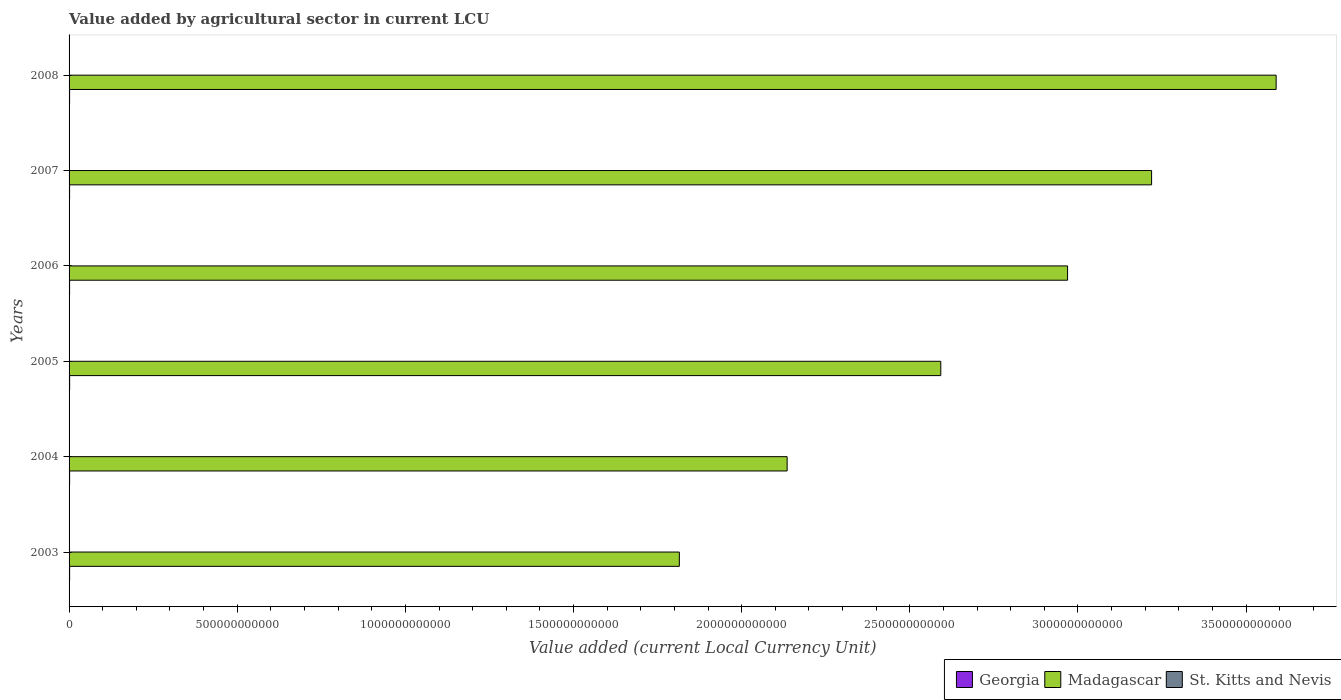How many different coloured bars are there?
Make the answer very short. 3. How many groups of bars are there?
Provide a short and direct response. 6. Are the number of bars on each tick of the Y-axis equal?
Make the answer very short. Yes. What is the label of the 4th group of bars from the top?
Ensure brevity in your answer.  2005. What is the value added by agricultural sector in St. Kitts and Nevis in 2006?
Your response must be concise. 2.07e+07. Across all years, what is the maximum value added by agricultural sector in St. Kitts and Nevis?
Keep it short and to the point. 2.57e+07. Across all years, what is the minimum value added by agricultural sector in St. Kitts and Nevis?
Your answer should be compact. 2.07e+07. In which year was the value added by agricultural sector in Georgia maximum?
Provide a succinct answer. 2005. What is the total value added by agricultural sector in Georgia in the graph?
Ensure brevity in your answer.  9.64e+09. What is the difference between the value added by agricultural sector in Georgia in 2003 and that in 2004?
Provide a short and direct response. 4.23e+07. What is the difference between the value added by agricultural sector in Georgia in 2005 and the value added by agricultural sector in Madagascar in 2007?
Your response must be concise. -3.22e+12. What is the average value added by agricultural sector in Madagascar per year?
Your answer should be compact. 2.72e+12. In the year 2006, what is the difference between the value added by agricultural sector in St. Kitts and Nevis and value added by agricultural sector in Georgia?
Offer a very short reply. -1.52e+09. In how many years, is the value added by agricultural sector in St. Kitts and Nevis greater than 3200000000000 LCU?
Give a very brief answer. 0. What is the ratio of the value added by agricultural sector in Madagascar in 2005 to that in 2008?
Provide a succinct answer. 0.72. What is the difference between the highest and the second highest value added by agricultural sector in Madagascar?
Ensure brevity in your answer.  3.70e+11. What is the difference between the highest and the lowest value added by agricultural sector in Madagascar?
Make the answer very short. 1.77e+12. Is the sum of the value added by agricultural sector in Madagascar in 2004 and 2005 greater than the maximum value added by agricultural sector in St. Kitts and Nevis across all years?
Your answer should be compact. Yes. What does the 1st bar from the top in 2003 represents?
Keep it short and to the point. St. Kitts and Nevis. What does the 3rd bar from the bottom in 2005 represents?
Offer a terse response. St. Kitts and Nevis. How many bars are there?
Ensure brevity in your answer.  18. Are all the bars in the graph horizontal?
Your answer should be very brief. Yes. How many years are there in the graph?
Provide a short and direct response. 6. What is the difference between two consecutive major ticks on the X-axis?
Keep it short and to the point. 5.00e+11. Are the values on the major ticks of X-axis written in scientific E-notation?
Offer a very short reply. No. Does the graph contain grids?
Your response must be concise. No. What is the title of the graph?
Your answer should be compact. Value added by agricultural sector in current LCU. Does "Greece" appear as one of the legend labels in the graph?
Provide a short and direct response. No. What is the label or title of the X-axis?
Offer a terse response. Value added (current Local Currency Unit). What is the Value added (current Local Currency Unit) of Georgia in 2003?
Make the answer very short. 1.65e+09. What is the Value added (current Local Currency Unit) in Madagascar in 2003?
Your answer should be compact. 1.81e+12. What is the Value added (current Local Currency Unit) in St. Kitts and Nevis in 2003?
Provide a short and direct response. 2.26e+07. What is the Value added (current Local Currency Unit) of Georgia in 2004?
Offer a very short reply. 1.61e+09. What is the Value added (current Local Currency Unit) of Madagascar in 2004?
Ensure brevity in your answer.  2.14e+12. What is the Value added (current Local Currency Unit) of St. Kitts and Nevis in 2004?
Make the answer very short. 2.44e+07. What is the Value added (current Local Currency Unit) in Georgia in 2005?
Offer a terse response. 1.72e+09. What is the Value added (current Local Currency Unit) in Madagascar in 2005?
Your answer should be compact. 2.59e+12. What is the Value added (current Local Currency Unit) in St. Kitts and Nevis in 2005?
Ensure brevity in your answer.  2.45e+07. What is the Value added (current Local Currency Unit) in Georgia in 2006?
Provide a short and direct response. 1.54e+09. What is the Value added (current Local Currency Unit) of Madagascar in 2006?
Your answer should be very brief. 2.97e+12. What is the Value added (current Local Currency Unit) of St. Kitts and Nevis in 2006?
Keep it short and to the point. 2.07e+07. What is the Value added (current Local Currency Unit) in Georgia in 2007?
Offer a terse response. 1.56e+09. What is the Value added (current Local Currency Unit) in Madagascar in 2007?
Offer a very short reply. 3.22e+12. What is the Value added (current Local Currency Unit) in St. Kitts and Nevis in 2007?
Your answer should be compact. 2.15e+07. What is the Value added (current Local Currency Unit) in Georgia in 2008?
Provide a succinct answer. 1.55e+09. What is the Value added (current Local Currency Unit) of Madagascar in 2008?
Provide a short and direct response. 3.59e+12. What is the Value added (current Local Currency Unit) of St. Kitts and Nevis in 2008?
Provide a short and direct response. 2.57e+07. Across all years, what is the maximum Value added (current Local Currency Unit) in Georgia?
Give a very brief answer. 1.72e+09. Across all years, what is the maximum Value added (current Local Currency Unit) in Madagascar?
Provide a succinct answer. 3.59e+12. Across all years, what is the maximum Value added (current Local Currency Unit) in St. Kitts and Nevis?
Offer a terse response. 2.57e+07. Across all years, what is the minimum Value added (current Local Currency Unit) of Georgia?
Your answer should be compact. 1.54e+09. Across all years, what is the minimum Value added (current Local Currency Unit) in Madagascar?
Make the answer very short. 1.81e+12. Across all years, what is the minimum Value added (current Local Currency Unit) in St. Kitts and Nevis?
Keep it short and to the point. 2.07e+07. What is the total Value added (current Local Currency Unit) in Georgia in the graph?
Your answer should be very brief. 9.64e+09. What is the total Value added (current Local Currency Unit) of Madagascar in the graph?
Ensure brevity in your answer.  1.63e+13. What is the total Value added (current Local Currency Unit) of St. Kitts and Nevis in the graph?
Your answer should be compact. 1.39e+08. What is the difference between the Value added (current Local Currency Unit) of Georgia in 2003 and that in 2004?
Your answer should be very brief. 4.23e+07. What is the difference between the Value added (current Local Currency Unit) in Madagascar in 2003 and that in 2004?
Offer a terse response. -3.21e+11. What is the difference between the Value added (current Local Currency Unit) in St. Kitts and Nevis in 2003 and that in 2004?
Ensure brevity in your answer.  -1.83e+06. What is the difference between the Value added (current Local Currency Unit) of Georgia in 2003 and that in 2005?
Your answer should be compact. -6.34e+07. What is the difference between the Value added (current Local Currency Unit) of Madagascar in 2003 and that in 2005?
Provide a short and direct response. -7.77e+11. What is the difference between the Value added (current Local Currency Unit) of St. Kitts and Nevis in 2003 and that in 2005?
Keep it short and to the point. -1.98e+06. What is the difference between the Value added (current Local Currency Unit) of Georgia in 2003 and that in 2006?
Your answer should be compact. 1.09e+08. What is the difference between the Value added (current Local Currency Unit) in Madagascar in 2003 and that in 2006?
Your answer should be compact. -1.15e+12. What is the difference between the Value added (current Local Currency Unit) of St. Kitts and Nevis in 2003 and that in 2006?
Keep it short and to the point. 1.88e+06. What is the difference between the Value added (current Local Currency Unit) of Georgia in 2003 and that in 2007?
Offer a very short reply. 9.02e+07. What is the difference between the Value added (current Local Currency Unit) in Madagascar in 2003 and that in 2007?
Ensure brevity in your answer.  -1.40e+12. What is the difference between the Value added (current Local Currency Unit) in St. Kitts and Nevis in 2003 and that in 2007?
Your answer should be very brief. 1.06e+06. What is the difference between the Value added (current Local Currency Unit) in Georgia in 2003 and that in 2008?
Provide a short and direct response. 1.02e+08. What is the difference between the Value added (current Local Currency Unit) in Madagascar in 2003 and that in 2008?
Keep it short and to the point. -1.77e+12. What is the difference between the Value added (current Local Currency Unit) of St. Kitts and Nevis in 2003 and that in 2008?
Your answer should be very brief. -3.13e+06. What is the difference between the Value added (current Local Currency Unit) of Georgia in 2004 and that in 2005?
Your answer should be compact. -1.06e+08. What is the difference between the Value added (current Local Currency Unit) in Madagascar in 2004 and that in 2005?
Make the answer very short. -4.57e+11. What is the difference between the Value added (current Local Currency Unit) of St. Kitts and Nevis in 2004 and that in 2005?
Give a very brief answer. -1.56e+05. What is the difference between the Value added (current Local Currency Unit) of Georgia in 2004 and that in 2006?
Give a very brief answer. 6.63e+07. What is the difference between the Value added (current Local Currency Unit) of Madagascar in 2004 and that in 2006?
Offer a terse response. -8.34e+11. What is the difference between the Value added (current Local Currency Unit) of St. Kitts and Nevis in 2004 and that in 2006?
Your answer should be very brief. 3.71e+06. What is the difference between the Value added (current Local Currency Unit) in Georgia in 2004 and that in 2007?
Keep it short and to the point. 4.80e+07. What is the difference between the Value added (current Local Currency Unit) in Madagascar in 2004 and that in 2007?
Ensure brevity in your answer.  -1.08e+12. What is the difference between the Value added (current Local Currency Unit) of St. Kitts and Nevis in 2004 and that in 2007?
Give a very brief answer. 2.89e+06. What is the difference between the Value added (current Local Currency Unit) in Georgia in 2004 and that in 2008?
Provide a short and direct response. 5.96e+07. What is the difference between the Value added (current Local Currency Unit) of Madagascar in 2004 and that in 2008?
Offer a very short reply. -1.45e+12. What is the difference between the Value added (current Local Currency Unit) in St. Kitts and Nevis in 2004 and that in 2008?
Make the answer very short. -1.30e+06. What is the difference between the Value added (current Local Currency Unit) of Georgia in 2005 and that in 2006?
Provide a short and direct response. 1.72e+08. What is the difference between the Value added (current Local Currency Unit) in Madagascar in 2005 and that in 2006?
Provide a short and direct response. -3.77e+11. What is the difference between the Value added (current Local Currency Unit) in St. Kitts and Nevis in 2005 and that in 2006?
Ensure brevity in your answer.  3.87e+06. What is the difference between the Value added (current Local Currency Unit) in Georgia in 2005 and that in 2007?
Make the answer very short. 1.54e+08. What is the difference between the Value added (current Local Currency Unit) of Madagascar in 2005 and that in 2007?
Keep it short and to the point. -6.27e+11. What is the difference between the Value added (current Local Currency Unit) in St. Kitts and Nevis in 2005 and that in 2007?
Keep it short and to the point. 3.05e+06. What is the difference between the Value added (current Local Currency Unit) in Georgia in 2005 and that in 2008?
Your answer should be compact. 1.65e+08. What is the difference between the Value added (current Local Currency Unit) of Madagascar in 2005 and that in 2008?
Provide a short and direct response. -9.97e+11. What is the difference between the Value added (current Local Currency Unit) in St. Kitts and Nevis in 2005 and that in 2008?
Offer a very short reply. -1.14e+06. What is the difference between the Value added (current Local Currency Unit) of Georgia in 2006 and that in 2007?
Your answer should be compact. -1.84e+07. What is the difference between the Value added (current Local Currency Unit) in Madagascar in 2006 and that in 2007?
Keep it short and to the point. -2.50e+11. What is the difference between the Value added (current Local Currency Unit) in St. Kitts and Nevis in 2006 and that in 2007?
Provide a succinct answer. -8.18e+05. What is the difference between the Value added (current Local Currency Unit) in Georgia in 2006 and that in 2008?
Keep it short and to the point. -6.71e+06. What is the difference between the Value added (current Local Currency Unit) of Madagascar in 2006 and that in 2008?
Offer a terse response. -6.20e+11. What is the difference between the Value added (current Local Currency Unit) in St. Kitts and Nevis in 2006 and that in 2008?
Offer a very short reply. -5.01e+06. What is the difference between the Value added (current Local Currency Unit) of Georgia in 2007 and that in 2008?
Your answer should be compact. 1.17e+07. What is the difference between the Value added (current Local Currency Unit) in Madagascar in 2007 and that in 2008?
Keep it short and to the point. -3.70e+11. What is the difference between the Value added (current Local Currency Unit) of St. Kitts and Nevis in 2007 and that in 2008?
Provide a succinct answer. -4.19e+06. What is the difference between the Value added (current Local Currency Unit) of Georgia in 2003 and the Value added (current Local Currency Unit) of Madagascar in 2004?
Provide a short and direct response. -2.13e+12. What is the difference between the Value added (current Local Currency Unit) of Georgia in 2003 and the Value added (current Local Currency Unit) of St. Kitts and Nevis in 2004?
Provide a succinct answer. 1.63e+09. What is the difference between the Value added (current Local Currency Unit) of Madagascar in 2003 and the Value added (current Local Currency Unit) of St. Kitts and Nevis in 2004?
Ensure brevity in your answer.  1.81e+12. What is the difference between the Value added (current Local Currency Unit) in Georgia in 2003 and the Value added (current Local Currency Unit) in Madagascar in 2005?
Ensure brevity in your answer.  -2.59e+12. What is the difference between the Value added (current Local Currency Unit) of Georgia in 2003 and the Value added (current Local Currency Unit) of St. Kitts and Nevis in 2005?
Keep it short and to the point. 1.63e+09. What is the difference between the Value added (current Local Currency Unit) in Madagascar in 2003 and the Value added (current Local Currency Unit) in St. Kitts and Nevis in 2005?
Your answer should be compact. 1.81e+12. What is the difference between the Value added (current Local Currency Unit) in Georgia in 2003 and the Value added (current Local Currency Unit) in Madagascar in 2006?
Offer a terse response. -2.97e+12. What is the difference between the Value added (current Local Currency Unit) in Georgia in 2003 and the Value added (current Local Currency Unit) in St. Kitts and Nevis in 2006?
Provide a succinct answer. 1.63e+09. What is the difference between the Value added (current Local Currency Unit) in Madagascar in 2003 and the Value added (current Local Currency Unit) in St. Kitts and Nevis in 2006?
Your answer should be very brief. 1.81e+12. What is the difference between the Value added (current Local Currency Unit) in Georgia in 2003 and the Value added (current Local Currency Unit) in Madagascar in 2007?
Offer a very short reply. -3.22e+12. What is the difference between the Value added (current Local Currency Unit) in Georgia in 2003 and the Value added (current Local Currency Unit) in St. Kitts and Nevis in 2007?
Your response must be concise. 1.63e+09. What is the difference between the Value added (current Local Currency Unit) in Madagascar in 2003 and the Value added (current Local Currency Unit) in St. Kitts and Nevis in 2007?
Ensure brevity in your answer.  1.81e+12. What is the difference between the Value added (current Local Currency Unit) in Georgia in 2003 and the Value added (current Local Currency Unit) in Madagascar in 2008?
Your response must be concise. -3.59e+12. What is the difference between the Value added (current Local Currency Unit) in Georgia in 2003 and the Value added (current Local Currency Unit) in St. Kitts and Nevis in 2008?
Your answer should be very brief. 1.63e+09. What is the difference between the Value added (current Local Currency Unit) in Madagascar in 2003 and the Value added (current Local Currency Unit) in St. Kitts and Nevis in 2008?
Keep it short and to the point. 1.81e+12. What is the difference between the Value added (current Local Currency Unit) in Georgia in 2004 and the Value added (current Local Currency Unit) in Madagascar in 2005?
Your answer should be compact. -2.59e+12. What is the difference between the Value added (current Local Currency Unit) of Georgia in 2004 and the Value added (current Local Currency Unit) of St. Kitts and Nevis in 2005?
Make the answer very short. 1.59e+09. What is the difference between the Value added (current Local Currency Unit) of Madagascar in 2004 and the Value added (current Local Currency Unit) of St. Kitts and Nevis in 2005?
Give a very brief answer. 2.14e+12. What is the difference between the Value added (current Local Currency Unit) of Georgia in 2004 and the Value added (current Local Currency Unit) of Madagascar in 2006?
Give a very brief answer. -2.97e+12. What is the difference between the Value added (current Local Currency Unit) in Georgia in 2004 and the Value added (current Local Currency Unit) in St. Kitts and Nevis in 2006?
Make the answer very short. 1.59e+09. What is the difference between the Value added (current Local Currency Unit) of Madagascar in 2004 and the Value added (current Local Currency Unit) of St. Kitts and Nevis in 2006?
Your answer should be very brief. 2.14e+12. What is the difference between the Value added (current Local Currency Unit) in Georgia in 2004 and the Value added (current Local Currency Unit) in Madagascar in 2007?
Make the answer very short. -3.22e+12. What is the difference between the Value added (current Local Currency Unit) of Georgia in 2004 and the Value added (current Local Currency Unit) of St. Kitts and Nevis in 2007?
Ensure brevity in your answer.  1.59e+09. What is the difference between the Value added (current Local Currency Unit) in Madagascar in 2004 and the Value added (current Local Currency Unit) in St. Kitts and Nevis in 2007?
Offer a terse response. 2.14e+12. What is the difference between the Value added (current Local Currency Unit) of Georgia in 2004 and the Value added (current Local Currency Unit) of Madagascar in 2008?
Your answer should be compact. -3.59e+12. What is the difference between the Value added (current Local Currency Unit) in Georgia in 2004 and the Value added (current Local Currency Unit) in St. Kitts and Nevis in 2008?
Your answer should be very brief. 1.58e+09. What is the difference between the Value added (current Local Currency Unit) of Madagascar in 2004 and the Value added (current Local Currency Unit) of St. Kitts and Nevis in 2008?
Your answer should be compact. 2.14e+12. What is the difference between the Value added (current Local Currency Unit) in Georgia in 2005 and the Value added (current Local Currency Unit) in Madagascar in 2006?
Your answer should be compact. -2.97e+12. What is the difference between the Value added (current Local Currency Unit) of Georgia in 2005 and the Value added (current Local Currency Unit) of St. Kitts and Nevis in 2006?
Your answer should be compact. 1.70e+09. What is the difference between the Value added (current Local Currency Unit) in Madagascar in 2005 and the Value added (current Local Currency Unit) in St. Kitts and Nevis in 2006?
Make the answer very short. 2.59e+12. What is the difference between the Value added (current Local Currency Unit) of Georgia in 2005 and the Value added (current Local Currency Unit) of Madagascar in 2007?
Provide a short and direct response. -3.22e+12. What is the difference between the Value added (current Local Currency Unit) in Georgia in 2005 and the Value added (current Local Currency Unit) in St. Kitts and Nevis in 2007?
Offer a terse response. 1.69e+09. What is the difference between the Value added (current Local Currency Unit) in Madagascar in 2005 and the Value added (current Local Currency Unit) in St. Kitts and Nevis in 2007?
Give a very brief answer. 2.59e+12. What is the difference between the Value added (current Local Currency Unit) of Georgia in 2005 and the Value added (current Local Currency Unit) of Madagascar in 2008?
Make the answer very short. -3.59e+12. What is the difference between the Value added (current Local Currency Unit) of Georgia in 2005 and the Value added (current Local Currency Unit) of St. Kitts and Nevis in 2008?
Keep it short and to the point. 1.69e+09. What is the difference between the Value added (current Local Currency Unit) in Madagascar in 2005 and the Value added (current Local Currency Unit) in St. Kitts and Nevis in 2008?
Keep it short and to the point. 2.59e+12. What is the difference between the Value added (current Local Currency Unit) in Georgia in 2006 and the Value added (current Local Currency Unit) in Madagascar in 2007?
Make the answer very short. -3.22e+12. What is the difference between the Value added (current Local Currency Unit) of Georgia in 2006 and the Value added (current Local Currency Unit) of St. Kitts and Nevis in 2007?
Your answer should be very brief. 1.52e+09. What is the difference between the Value added (current Local Currency Unit) in Madagascar in 2006 and the Value added (current Local Currency Unit) in St. Kitts and Nevis in 2007?
Keep it short and to the point. 2.97e+12. What is the difference between the Value added (current Local Currency Unit) of Georgia in 2006 and the Value added (current Local Currency Unit) of Madagascar in 2008?
Offer a terse response. -3.59e+12. What is the difference between the Value added (current Local Currency Unit) in Georgia in 2006 and the Value added (current Local Currency Unit) in St. Kitts and Nevis in 2008?
Your answer should be compact. 1.52e+09. What is the difference between the Value added (current Local Currency Unit) in Madagascar in 2006 and the Value added (current Local Currency Unit) in St. Kitts and Nevis in 2008?
Make the answer very short. 2.97e+12. What is the difference between the Value added (current Local Currency Unit) in Georgia in 2007 and the Value added (current Local Currency Unit) in Madagascar in 2008?
Keep it short and to the point. -3.59e+12. What is the difference between the Value added (current Local Currency Unit) of Georgia in 2007 and the Value added (current Local Currency Unit) of St. Kitts and Nevis in 2008?
Give a very brief answer. 1.54e+09. What is the difference between the Value added (current Local Currency Unit) of Madagascar in 2007 and the Value added (current Local Currency Unit) of St. Kitts and Nevis in 2008?
Your answer should be very brief. 3.22e+12. What is the average Value added (current Local Currency Unit) in Georgia per year?
Provide a succinct answer. 1.61e+09. What is the average Value added (current Local Currency Unit) of Madagascar per year?
Provide a short and direct response. 2.72e+12. What is the average Value added (current Local Currency Unit) of St. Kitts and Nevis per year?
Provide a short and direct response. 2.32e+07. In the year 2003, what is the difference between the Value added (current Local Currency Unit) of Georgia and Value added (current Local Currency Unit) of Madagascar?
Your answer should be compact. -1.81e+12. In the year 2003, what is the difference between the Value added (current Local Currency Unit) in Georgia and Value added (current Local Currency Unit) in St. Kitts and Nevis?
Keep it short and to the point. 1.63e+09. In the year 2003, what is the difference between the Value added (current Local Currency Unit) in Madagascar and Value added (current Local Currency Unit) in St. Kitts and Nevis?
Your answer should be compact. 1.81e+12. In the year 2004, what is the difference between the Value added (current Local Currency Unit) in Georgia and Value added (current Local Currency Unit) in Madagascar?
Your answer should be compact. -2.13e+12. In the year 2004, what is the difference between the Value added (current Local Currency Unit) of Georgia and Value added (current Local Currency Unit) of St. Kitts and Nevis?
Give a very brief answer. 1.59e+09. In the year 2004, what is the difference between the Value added (current Local Currency Unit) of Madagascar and Value added (current Local Currency Unit) of St. Kitts and Nevis?
Provide a succinct answer. 2.14e+12. In the year 2005, what is the difference between the Value added (current Local Currency Unit) in Georgia and Value added (current Local Currency Unit) in Madagascar?
Provide a succinct answer. -2.59e+12. In the year 2005, what is the difference between the Value added (current Local Currency Unit) in Georgia and Value added (current Local Currency Unit) in St. Kitts and Nevis?
Offer a terse response. 1.69e+09. In the year 2005, what is the difference between the Value added (current Local Currency Unit) in Madagascar and Value added (current Local Currency Unit) in St. Kitts and Nevis?
Your response must be concise. 2.59e+12. In the year 2006, what is the difference between the Value added (current Local Currency Unit) of Georgia and Value added (current Local Currency Unit) of Madagascar?
Provide a succinct answer. -2.97e+12. In the year 2006, what is the difference between the Value added (current Local Currency Unit) of Georgia and Value added (current Local Currency Unit) of St. Kitts and Nevis?
Your answer should be compact. 1.52e+09. In the year 2006, what is the difference between the Value added (current Local Currency Unit) in Madagascar and Value added (current Local Currency Unit) in St. Kitts and Nevis?
Ensure brevity in your answer.  2.97e+12. In the year 2007, what is the difference between the Value added (current Local Currency Unit) of Georgia and Value added (current Local Currency Unit) of Madagascar?
Offer a terse response. -3.22e+12. In the year 2007, what is the difference between the Value added (current Local Currency Unit) in Georgia and Value added (current Local Currency Unit) in St. Kitts and Nevis?
Provide a short and direct response. 1.54e+09. In the year 2007, what is the difference between the Value added (current Local Currency Unit) of Madagascar and Value added (current Local Currency Unit) of St. Kitts and Nevis?
Your response must be concise. 3.22e+12. In the year 2008, what is the difference between the Value added (current Local Currency Unit) in Georgia and Value added (current Local Currency Unit) in Madagascar?
Make the answer very short. -3.59e+12. In the year 2008, what is the difference between the Value added (current Local Currency Unit) in Georgia and Value added (current Local Currency Unit) in St. Kitts and Nevis?
Make the answer very short. 1.53e+09. In the year 2008, what is the difference between the Value added (current Local Currency Unit) in Madagascar and Value added (current Local Currency Unit) in St. Kitts and Nevis?
Provide a short and direct response. 3.59e+12. What is the ratio of the Value added (current Local Currency Unit) of Georgia in 2003 to that in 2004?
Provide a short and direct response. 1.03. What is the ratio of the Value added (current Local Currency Unit) in Madagascar in 2003 to that in 2004?
Give a very brief answer. 0.85. What is the ratio of the Value added (current Local Currency Unit) in St. Kitts and Nevis in 2003 to that in 2004?
Keep it short and to the point. 0.93. What is the ratio of the Value added (current Local Currency Unit) in Georgia in 2003 to that in 2005?
Give a very brief answer. 0.96. What is the ratio of the Value added (current Local Currency Unit) in Madagascar in 2003 to that in 2005?
Give a very brief answer. 0.7. What is the ratio of the Value added (current Local Currency Unit) of St. Kitts and Nevis in 2003 to that in 2005?
Make the answer very short. 0.92. What is the ratio of the Value added (current Local Currency Unit) in Georgia in 2003 to that in 2006?
Make the answer very short. 1.07. What is the ratio of the Value added (current Local Currency Unit) in Madagascar in 2003 to that in 2006?
Offer a terse response. 0.61. What is the ratio of the Value added (current Local Currency Unit) in St. Kitts and Nevis in 2003 to that in 2006?
Offer a terse response. 1.09. What is the ratio of the Value added (current Local Currency Unit) of Georgia in 2003 to that in 2007?
Keep it short and to the point. 1.06. What is the ratio of the Value added (current Local Currency Unit) in Madagascar in 2003 to that in 2007?
Offer a very short reply. 0.56. What is the ratio of the Value added (current Local Currency Unit) of St. Kitts and Nevis in 2003 to that in 2007?
Your answer should be compact. 1.05. What is the ratio of the Value added (current Local Currency Unit) of Georgia in 2003 to that in 2008?
Your answer should be very brief. 1.07. What is the ratio of the Value added (current Local Currency Unit) of Madagascar in 2003 to that in 2008?
Provide a succinct answer. 0.51. What is the ratio of the Value added (current Local Currency Unit) in St. Kitts and Nevis in 2003 to that in 2008?
Your answer should be very brief. 0.88. What is the ratio of the Value added (current Local Currency Unit) of Georgia in 2004 to that in 2005?
Give a very brief answer. 0.94. What is the ratio of the Value added (current Local Currency Unit) in Madagascar in 2004 to that in 2005?
Your response must be concise. 0.82. What is the ratio of the Value added (current Local Currency Unit) in St. Kitts and Nevis in 2004 to that in 2005?
Provide a succinct answer. 0.99. What is the ratio of the Value added (current Local Currency Unit) of Georgia in 2004 to that in 2006?
Offer a very short reply. 1.04. What is the ratio of the Value added (current Local Currency Unit) of Madagascar in 2004 to that in 2006?
Give a very brief answer. 0.72. What is the ratio of the Value added (current Local Currency Unit) of St. Kitts and Nevis in 2004 to that in 2006?
Your answer should be compact. 1.18. What is the ratio of the Value added (current Local Currency Unit) of Georgia in 2004 to that in 2007?
Provide a short and direct response. 1.03. What is the ratio of the Value added (current Local Currency Unit) in Madagascar in 2004 to that in 2007?
Your response must be concise. 0.66. What is the ratio of the Value added (current Local Currency Unit) in St. Kitts and Nevis in 2004 to that in 2007?
Give a very brief answer. 1.13. What is the ratio of the Value added (current Local Currency Unit) of Georgia in 2004 to that in 2008?
Your answer should be very brief. 1.04. What is the ratio of the Value added (current Local Currency Unit) in Madagascar in 2004 to that in 2008?
Your answer should be compact. 0.59. What is the ratio of the Value added (current Local Currency Unit) in St. Kitts and Nevis in 2004 to that in 2008?
Your response must be concise. 0.95. What is the ratio of the Value added (current Local Currency Unit) of Georgia in 2005 to that in 2006?
Keep it short and to the point. 1.11. What is the ratio of the Value added (current Local Currency Unit) of Madagascar in 2005 to that in 2006?
Ensure brevity in your answer.  0.87. What is the ratio of the Value added (current Local Currency Unit) in St. Kitts and Nevis in 2005 to that in 2006?
Your answer should be very brief. 1.19. What is the ratio of the Value added (current Local Currency Unit) of Georgia in 2005 to that in 2007?
Ensure brevity in your answer.  1.1. What is the ratio of the Value added (current Local Currency Unit) in Madagascar in 2005 to that in 2007?
Your answer should be very brief. 0.81. What is the ratio of the Value added (current Local Currency Unit) in St. Kitts and Nevis in 2005 to that in 2007?
Keep it short and to the point. 1.14. What is the ratio of the Value added (current Local Currency Unit) of Georgia in 2005 to that in 2008?
Your answer should be compact. 1.11. What is the ratio of the Value added (current Local Currency Unit) in Madagascar in 2005 to that in 2008?
Give a very brief answer. 0.72. What is the ratio of the Value added (current Local Currency Unit) of St. Kitts and Nevis in 2005 to that in 2008?
Provide a short and direct response. 0.96. What is the ratio of the Value added (current Local Currency Unit) of Madagascar in 2006 to that in 2007?
Offer a terse response. 0.92. What is the ratio of the Value added (current Local Currency Unit) of St. Kitts and Nevis in 2006 to that in 2007?
Your answer should be compact. 0.96. What is the ratio of the Value added (current Local Currency Unit) of Madagascar in 2006 to that in 2008?
Provide a short and direct response. 0.83. What is the ratio of the Value added (current Local Currency Unit) of St. Kitts and Nevis in 2006 to that in 2008?
Give a very brief answer. 0.8. What is the ratio of the Value added (current Local Currency Unit) of Georgia in 2007 to that in 2008?
Make the answer very short. 1.01. What is the ratio of the Value added (current Local Currency Unit) of Madagascar in 2007 to that in 2008?
Your answer should be very brief. 0.9. What is the ratio of the Value added (current Local Currency Unit) in St. Kitts and Nevis in 2007 to that in 2008?
Your response must be concise. 0.84. What is the difference between the highest and the second highest Value added (current Local Currency Unit) of Georgia?
Provide a short and direct response. 6.34e+07. What is the difference between the highest and the second highest Value added (current Local Currency Unit) of Madagascar?
Offer a very short reply. 3.70e+11. What is the difference between the highest and the second highest Value added (current Local Currency Unit) in St. Kitts and Nevis?
Make the answer very short. 1.14e+06. What is the difference between the highest and the lowest Value added (current Local Currency Unit) in Georgia?
Your response must be concise. 1.72e+08. What is the difference between the highest and the lowest Value added (current Local Currency Unit) in Madagascar?
Keep it short and to the point. 1.77e+12. What is the difference between the highest and the lowest Value added (current Local Currency Unit) in St. Kitts and Nevis?
Your response must be concise. 5.01e+06. 